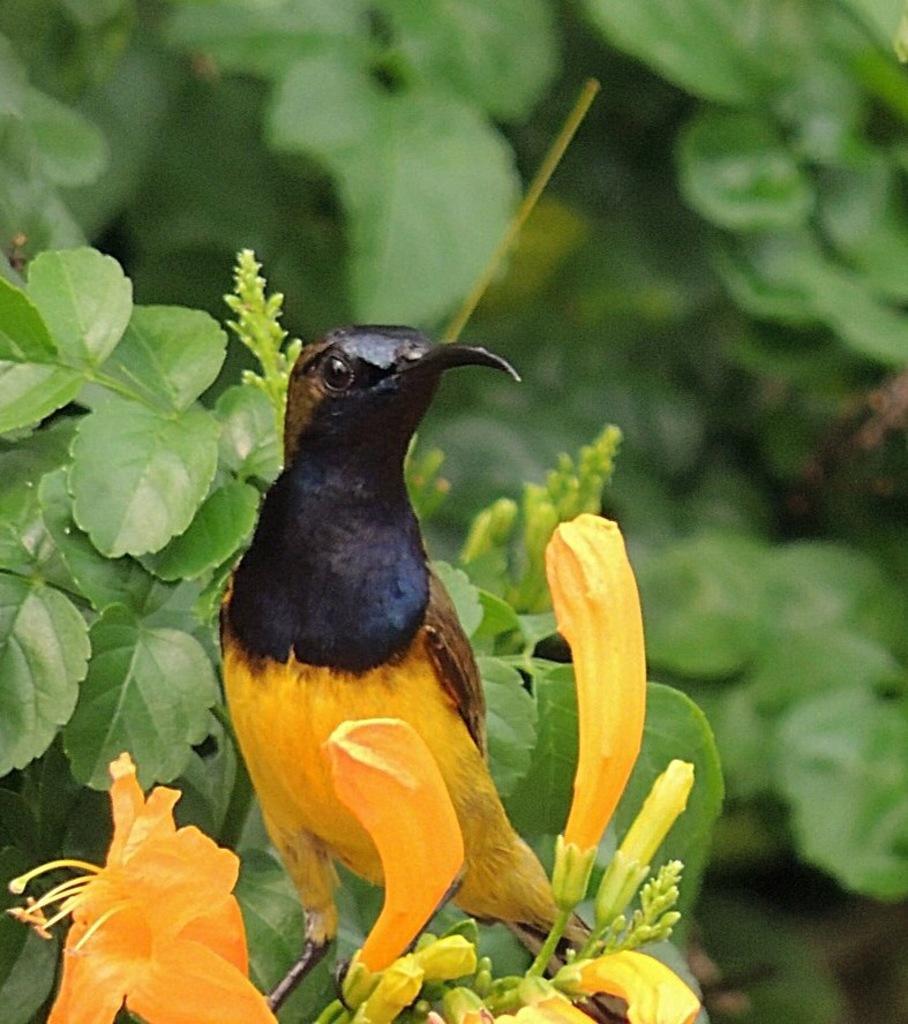In one or two sentences, can you explain what this image depicts? In this image there is a bird in yellow and black color. There are yellow color flowers in the foreground. There are leaves and trees in the background. 